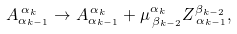Convert formula to latex. <formula><loc_0><loc_0><loc_500><loc_500>A _ { \alpha _ { k - 1 } } ^ { \, \alpha _ { k } } \rightarrow A _ { \alpha _ { k - 1 } } ^ { \, \alpha _ { k } } + \mu _ { \, \beta _ { k - 2 } } ^ { \alpha _ { k } } Z _ { \, \alpha _ { k - 1 } } ^ { \beta _ { k - 2 } } ,</formula> 